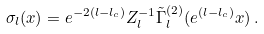<formula> <loc_0><loc_0><loc_500><loc_500>\sigma _ { l } ( x ) = e ^ { - 2 ( l - l _ { c } ) } Z _ { l } ^ { - 1 } \tilde { \Gamma } _ { l } ^ { ( 2 ) } ( e ^ { ( l - l _ { c } ) } x ) \, .</formula> 